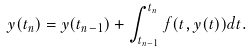Convert formula to latex. <formula><loc_0><loc_0><loc_500><loc_500>y ( t _ { n } ) = y ( t _ { n - 1 } ) + \int _ { t _ { n - 1 } } ^ { t _ { n } } f ( t , y ( t ) ) d t .</formula> 